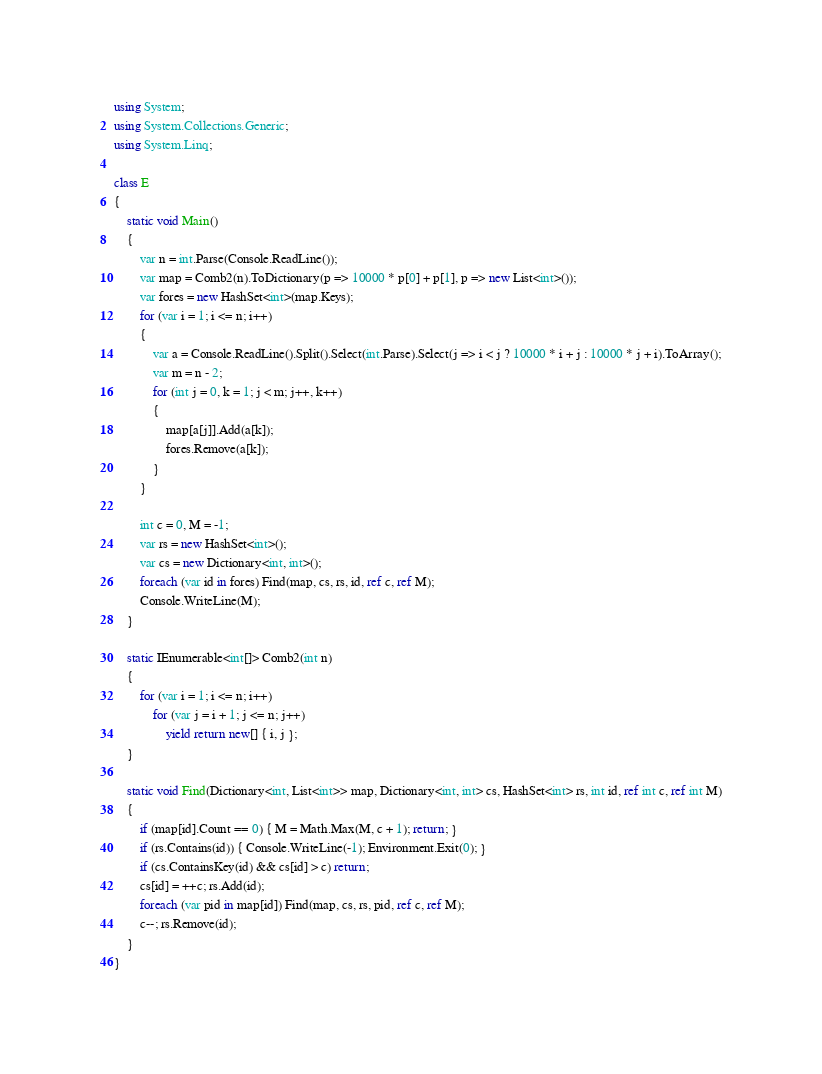Convert code to text. <code><loc_0><loc_0><loc_500><loc_500><_C#_>using System;
using System.Collections.Generic;
using System.Linq;

class E
{
	static void Main()
	{
		var n = int.Parse(Console.ReadLine());
		var map = Comb2(n).ToDictionary(p => 10000 * p[0] + p[1], p => new List<int>());
		var fores = new HashSet<int>(map.Keys);
		for (var i = 1; i <= n; i++)
		{
			var a = Console.ReadLine().Split().Select(int.Parse).Select(j => i < j ? 10000 * i + j : 10000 * j + i).ToArray();
			var m = n - 2;
			for (int j = 0, k = 1; j < m; j++, k++)
			{
				map[a[j]].Add(a[k]);
				fores.Remove(a[k]);
			}
		}

		int c = 0, M = -1;
		var rs = new HashSet<int>();
		var cs = new Dictionary<int, int>();
		foreach (var id in fores) Find(map, cs, rs, id, ref c, ref M);
		Console.WriteLine(M);
	}

	static IEnumerable<int[]> Comb2(int n)
	{
		for (var i = 1; i <= n; i++)
			for (var j = i + 1; j <= n; j++)
				yield return new[] { i, j };
	}

	static void Find(Dictionary<int, List<int>> map, Dictionary<int, int> cs, HashSet<int> rs, int id, ref int c, ref int M)
	{
		if (map[id].Count == 0) { M = Math.Max(M, c + 1); return; }
		if (rs.Contains(id)) { Console.WriteLine(-1); Environment.Exit(0); }
		if (cs.ContainsKey(id) && cs[id] > c) return;
		cs[id] = ++c; rs.Add(id);
		foreach (var pid in map[id]) Find(map, cs, rs, pid, ref c, ref M);
		c--; rs.Remove(id);
	}
}
</code> 